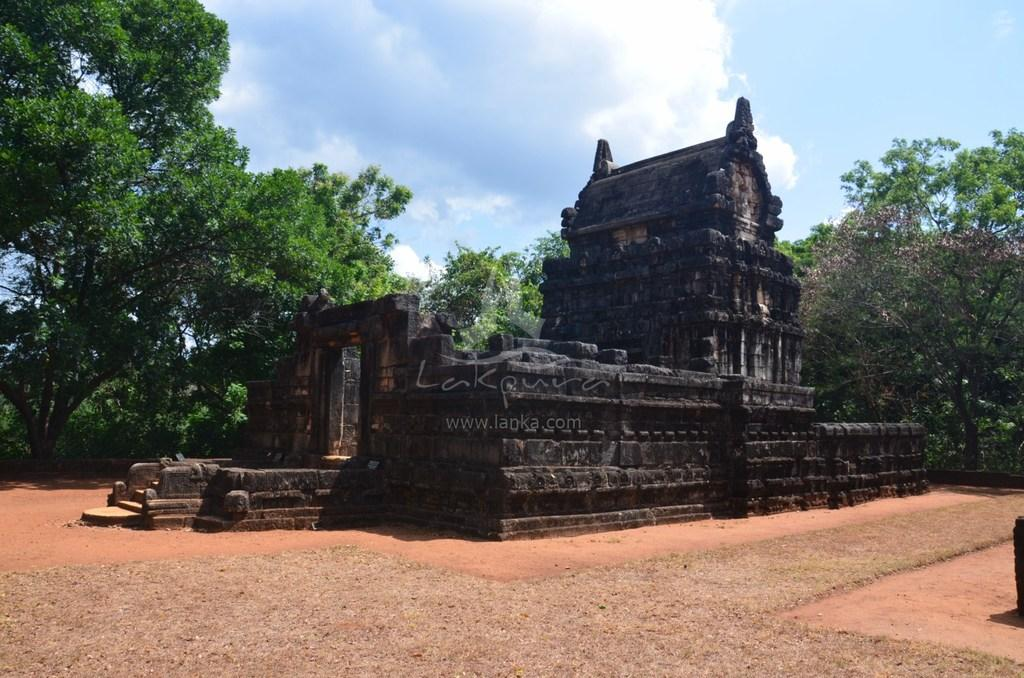What is the main subject in the image? There is a monument in the image. What is the color of the monument? The monument is black in color. What can be seen behind the monument? There are trees behind the monument. What is the color of the sky in the image? The sky is blue in color. Are there any additional features in the sky? Yes, there are clouds in the sky. How many cherries are on top of the monument in the image? There are no cherries present on top of the monument in the image. Is there a berry-picking lawyer in the image? There is no lawyer or berry-picking activity depicted in the image. 